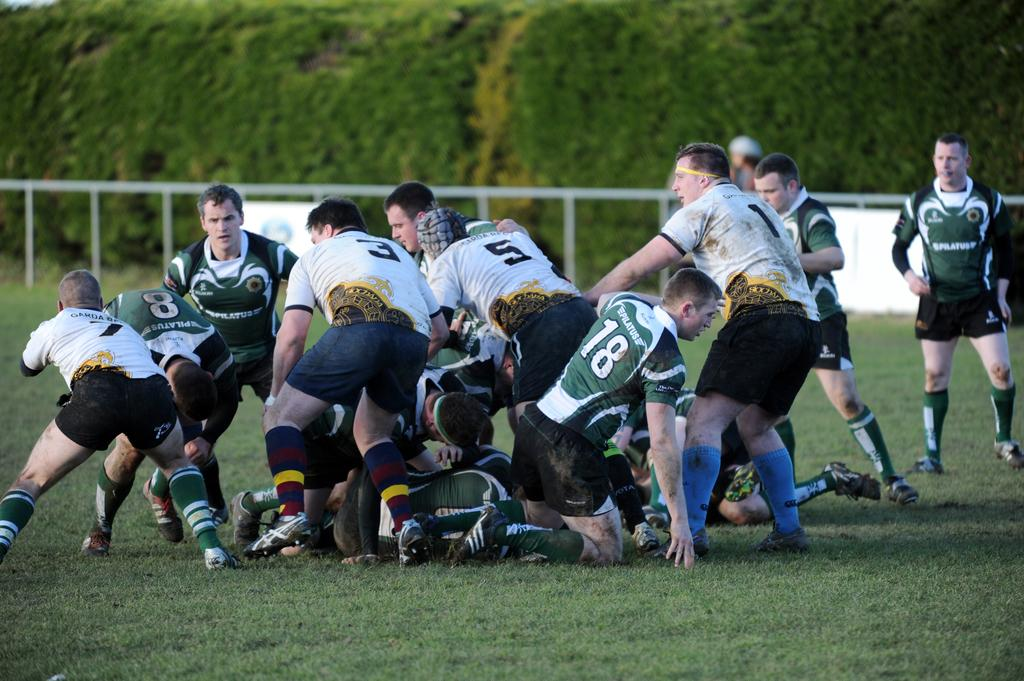What are the people in the image doing? The people in the image are playing. Where are the players located? The players are playing in a playground. What can be seen in the background of the image? There is a railing and trees in the background of the image. What type of jelly can be seen on the players' feet in the image? There is no jelly present on the players' feet in the image. What detail can be observed on the players' shoes in the image? The provided facts do not mention any specific details about the players' shoes, so we cannot answer this question definitively. 